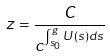Convert formula to latex. <formula><loc_0><loc_0><loc_500><loc_500>z = \frac { C } { c ^ { \int _ { s _ { 0 } } ^ { g } U ( s ) d s } }</formula> 